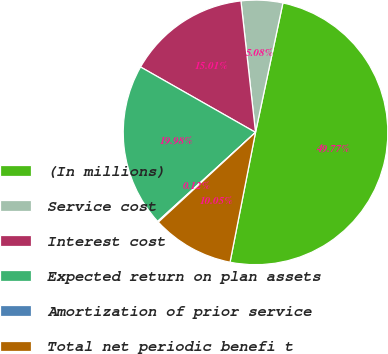<chart> <loc_0><loc_0><loc_500><loc_500><pie_chart><fcel>(In millions)<fcel>Service cost<fcel>Interest cost<fcel>Expected return on plan assets<fcel>Amortization of prior service<fcel>Total net periodic benefi t<nl><fcel>49.77%<fcel>5.08%<fcel>15.01%<fcel>19.98%<fcel>0.12%<fcel>10.05%<nl></chart> 